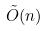<formula> <loc_0><loc_0><loc_500><loc_500>\tilde { O } ( n )</formula> 